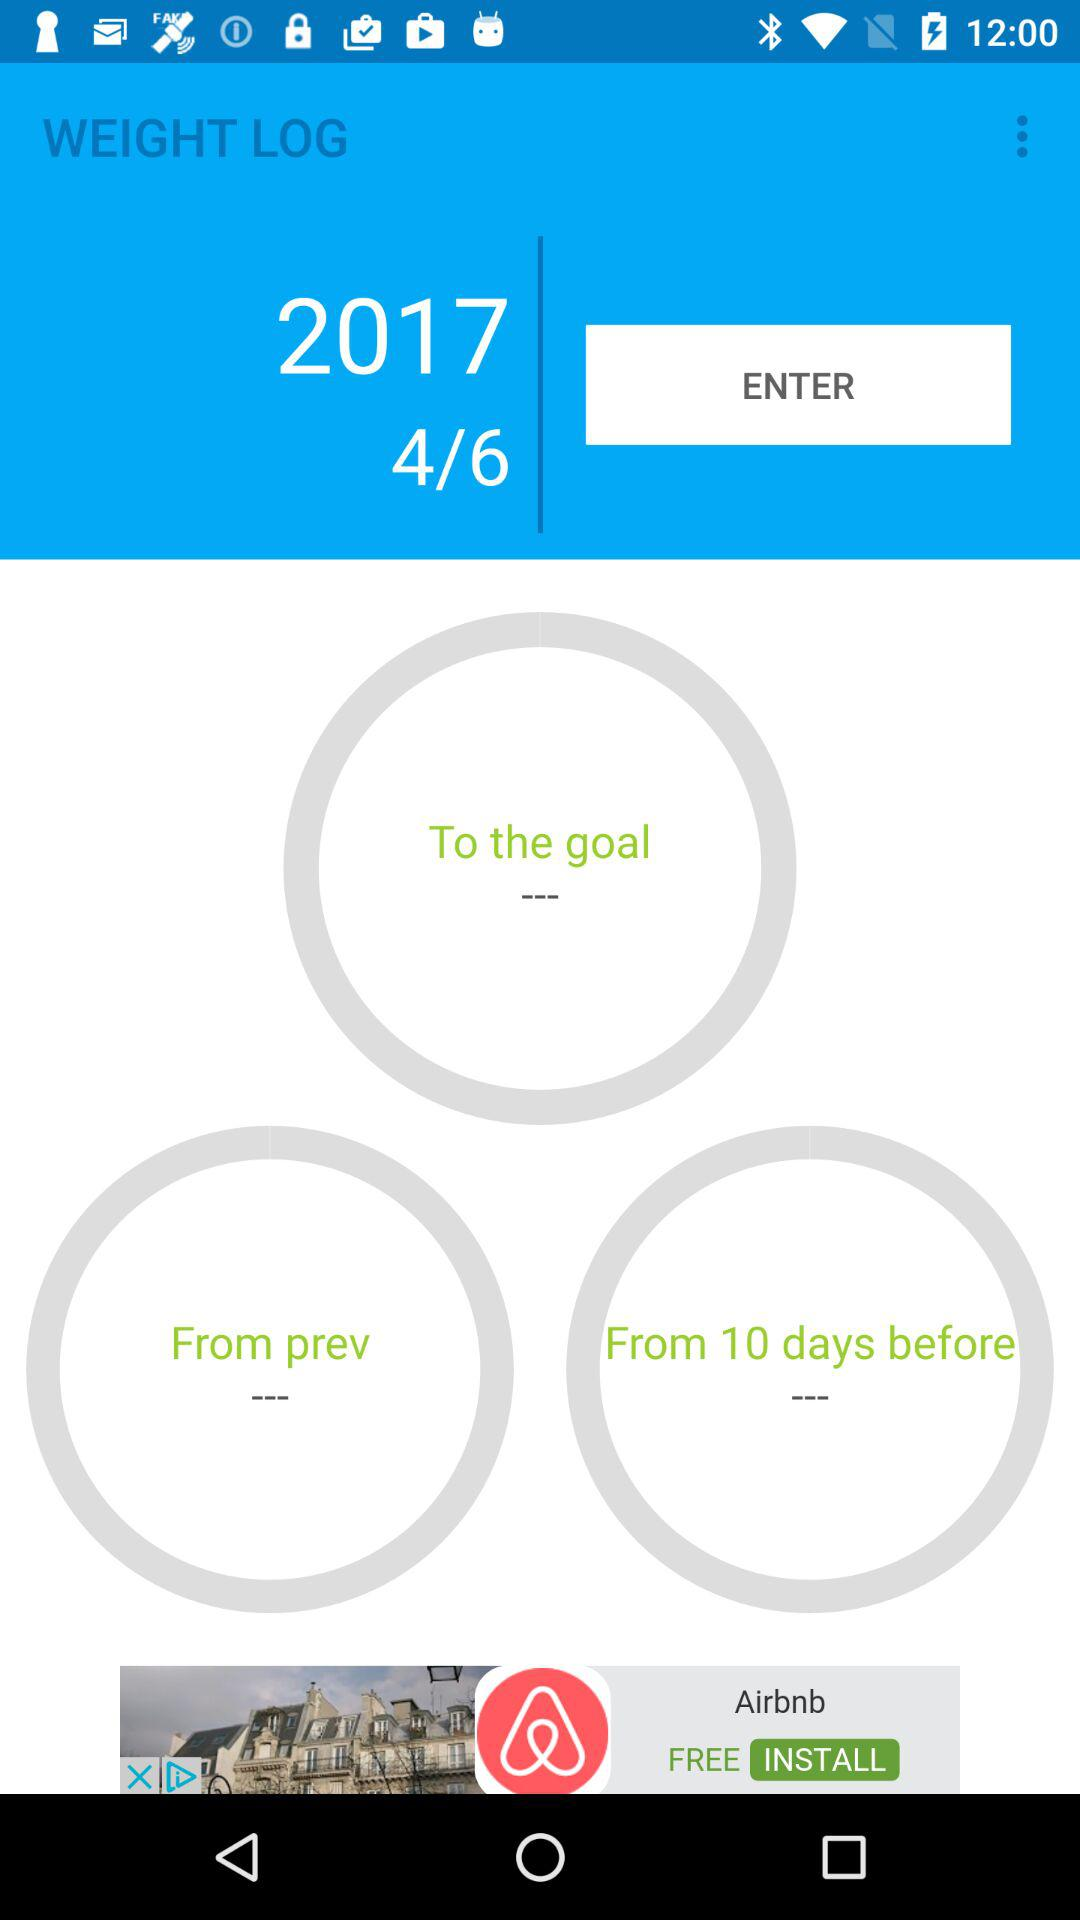What is the year? The year is 2017. 